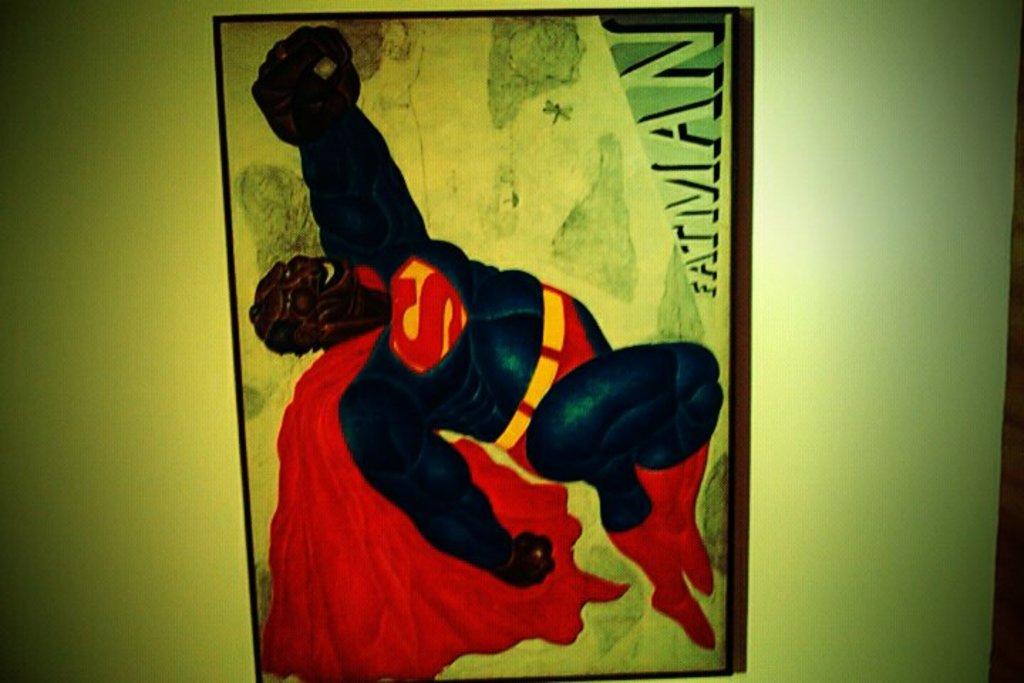What is the name of this superhero?
Offer a terse response. Fatman. 